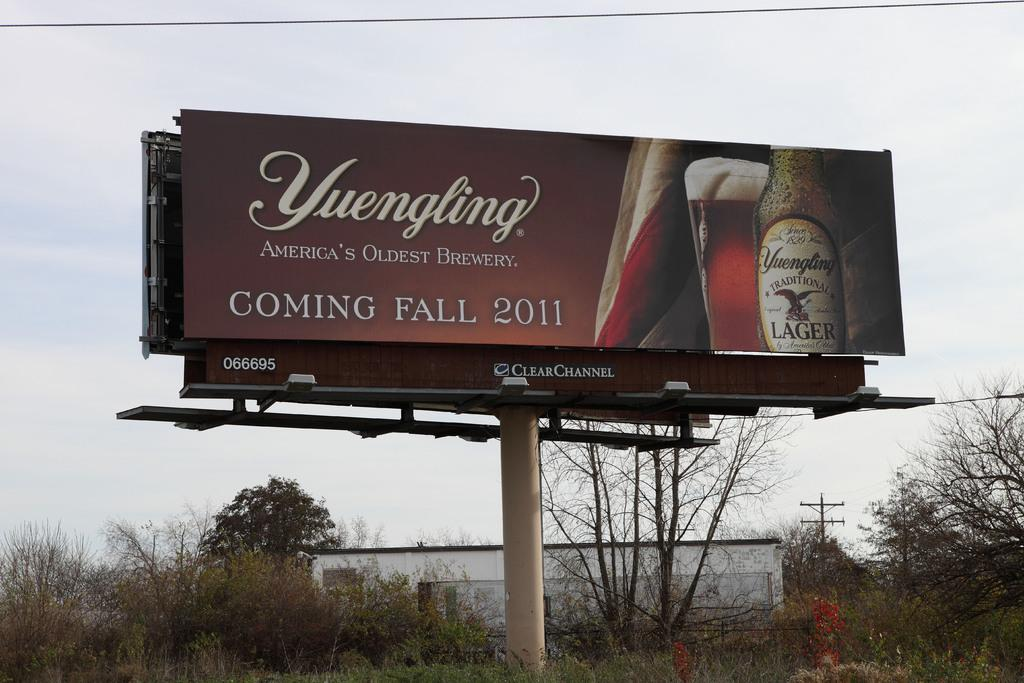<image>
Create a compact narrative representing the image presented. A billboard for a new beer product advertises that it's coming in fall 2011. 